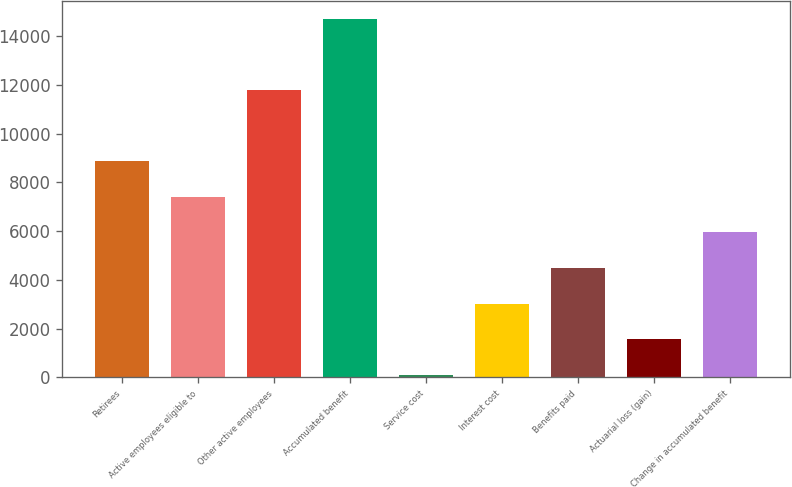<chart> <loc_0><loc_0><loc_500><loc_500><bar_chart><fcel>Retirees<fcel>Active employees eligible to<fcel>Other active employees<fcel>Accumulated benefit<fcel>Service cost<fcel>Interest cost<fcel>Benefits paid<fcel>Actuarial loss (gain)<fcel>Change in accumulated benefit<nl><fcel>8874.8<fcel>7411.5<fcel>11801.4<fcel>14728<fcel>95<fcel>3021.6<fcel>4484.9<fcel>1558.3<fcel>5948.2<nl></chart> 